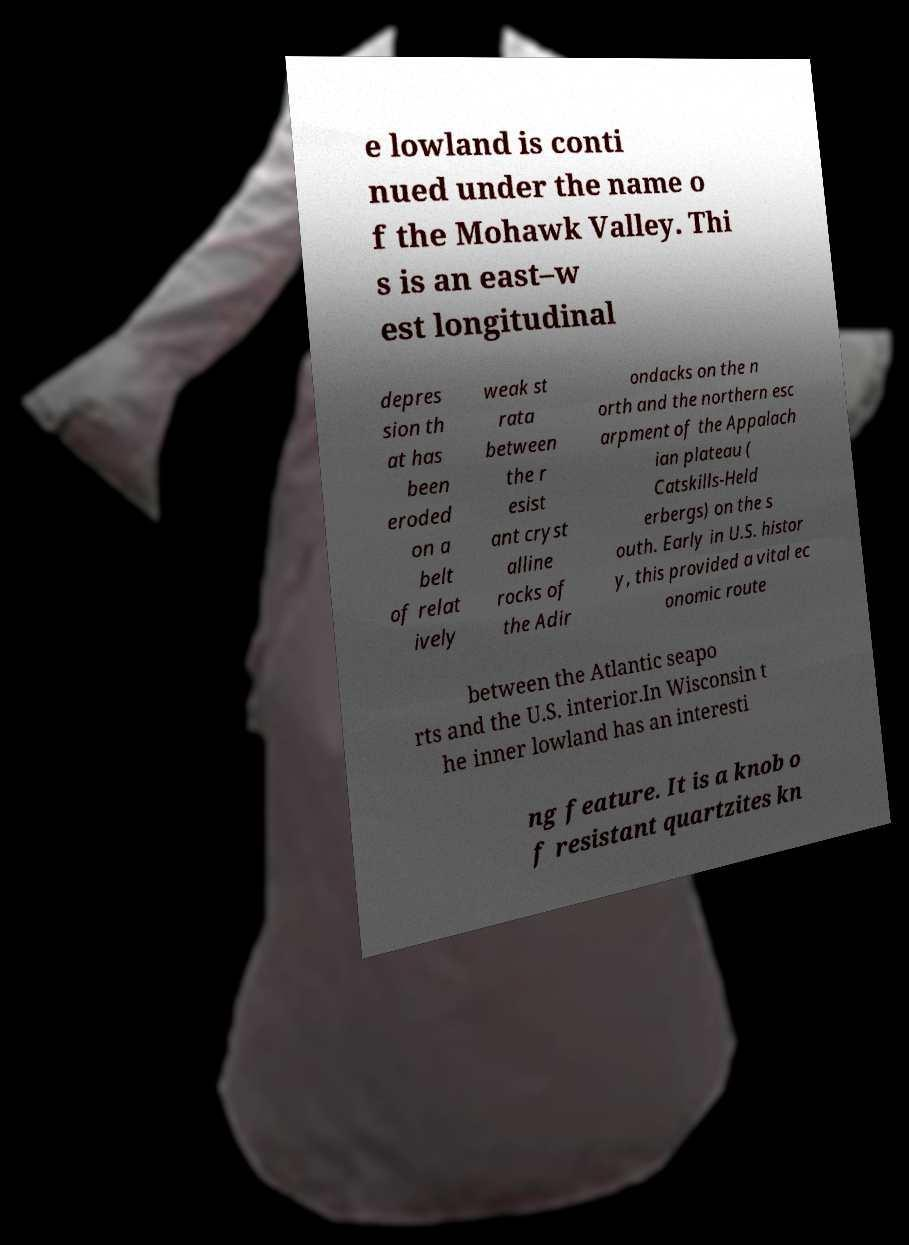Please read and relay the text visible in this image. What does it say? e lowland is conti nued under the name o f the Mohawk Valley. Thi s is an east–w est longitudinal depres sion th at has been eroded on a belt of relat ively weak st rata between the r esist ant cryst alline rocks of the Adir ondacks on the n orth and the northern esc arpment of the Appalach ian plateau ( Catskills-Held erbergs) on the s outh. Early in U.S. histor y, this provided a vital ec onomic route between the Atlantic seapo rts and the U.S. interior.In Wisconsin t he inner lowland has an interesti ng feature. It is a knob o f resistant quartzites kn 